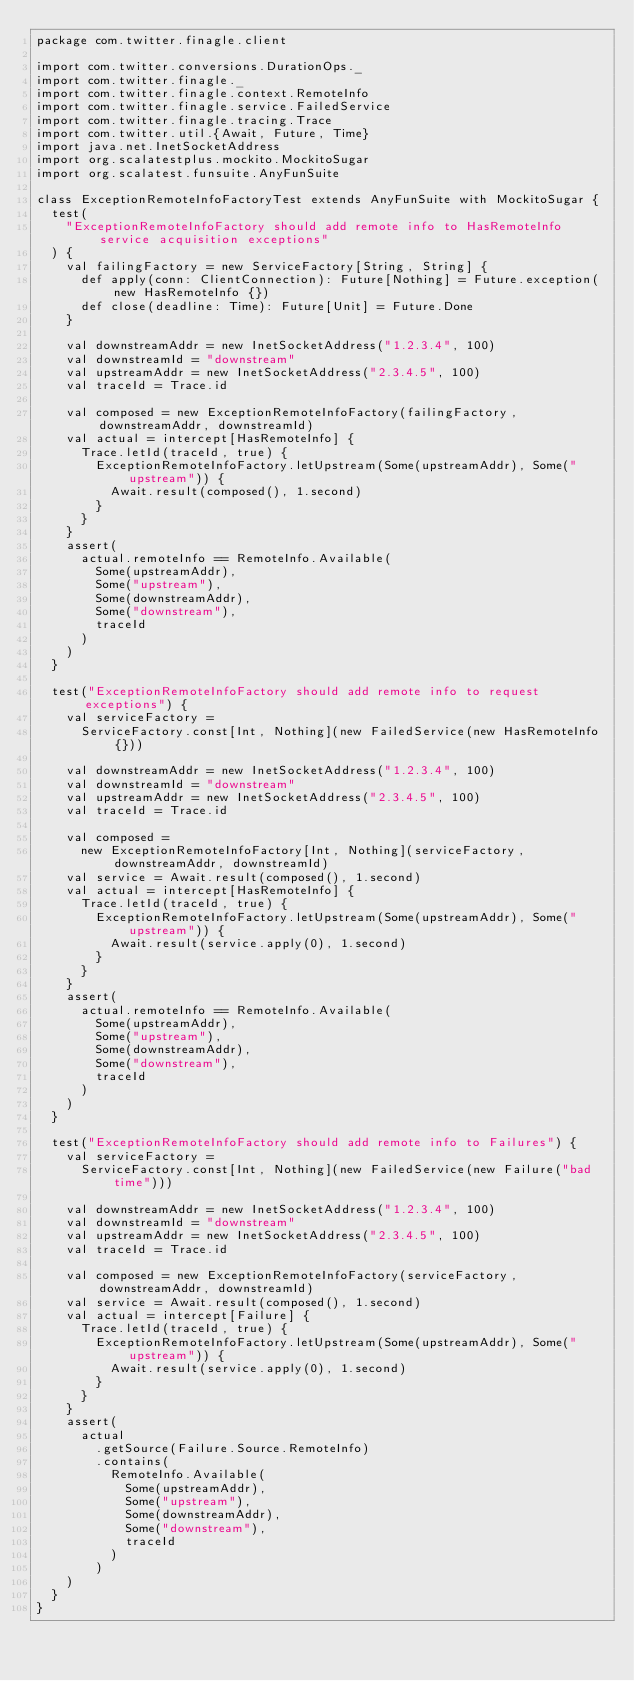Convert code to text. <code><loc_0><loc_0><loc_500><loc_500><_Scala_>package com.twitter.finagle.client

import com.twitter.conversions.DurationOps._
import com.twitter.finagle._
import com.twitter.finagle.context.RemoteInfo
import com.twitter.finagle.service.FailedService
import com.twitter.finagle.tracing.Trace
import com.twitter.util.{Await, Future, Time}
import java.net.InetSocketAddress
import org.scalatestplus.mockito.MockitoSugar
import org.scalatest.funsuite.AnyFunSuite

class ExceptionRemoteInfoFactoryTest extends AnyFunSuite with MockitoSugar {
  test(
    "ExceptionRemoteInfoFactory should add remote info to HasRemoteInfo service acquisition exceptions"
  ) {
    val failingFactory = new ServiceFactory[String, String] {
      def apply(conn: ClientConnection): Future[Nothing] = Future.exception(new HasRemoteInfo {})
      def close(deadline: Time): Future[Unit] = Future.Done
    }

    val downstreamAddr = new InetSocketAddress("1.2.3.4", 100)
    val downstreamId = "downstream"
    val upstreamAddr = new InetSocketAddress("2.3.4.5", 100)
    val traceId = Trace.id

    val composed = new ExceptionRemoteInfoFactory(failingFactory, downstreamAddr, downstreamId)
    val actual = intercept[HasRemoteInfo] {
      Trace.letId(traceId, true) {
        ExceptionRemoteInfoFactory.letUpstream(Some(upstreamAddr), Some("upstream")) {
          Await.result(composed(), 1.second)
        }
      }
    }
    assert(
      actual.remoteInfo == RemoteInfo.Available(
        Some(upstreamAddr),
        Some("upstream"),
        Some(downstreamAddr),
        Some("downstream"),
        traceId
      )
    )
  }

  test("ExceptionRemoteInfoFactory should add remote info to request exceptions") {
    val serviceFactory =
      ServiceFactory.const[Int, Nothing](new FailedService(new HasRemoteInfo {}))

    val downstreamAddr = new InetSocketAddress("1.2.3.4", 100)
    val downstreamId = "downstream"
    val upstreamAddr = new InetSocketAddress("2.3.4.5", 100)
    val traceId = Trace.id

    val composed =
      new ExceptionRemoteInfoFactory[Int, Nothing](serviceFactory, downstreamAddr, downstreamId)
    val service = Await.result(composed(), 1.second)
    val actual = intercept[HasRemoteInfo] {
      Trace.letId(traceId, true) {
        ExceptionRemoteInfoFactory.letUpstream(Some(upstreamAddr), Some("upstream")) {
          Await.result(service.apply(0), 1.second)
        }
      }
    }
    assert(
      actual.remoteInfo == RemoteInfo.Available(
        Some(upstreamAddr),
        Some("upstream"),
        Some(downstreamAddr),
        Some("downstream"),
        traceId
      )
    )
  }

  test("ExceptionRemoteInfoFactory should add remote info to Failures") {
    val serviceFactory =
      ServiceFactory.const[Int, Nothing](new FailedService(new Failure("bad time")))

    val downstreamAddr = new InetSocketAddress("1.2.3.4", 100)
    val downstreamId = "downstream"
    val upstreamAddr = new InetSocketAddress("2.3.4.5", 100)
    val traceId = Trace.id

    val composed = new ExceptionRemoteInfoFactory(serviceFactory, downstreamAddr, downstreamId)
    val service = Await.result(composed(), 1.second)
    val actual = intercept[Failure] {
      Trace.letId(traceId, true) {
        ExceptionRemoteInfoFactory.letUpstream(Some(upstreamAddr), Some("upstream")) {
          Await.result(service.apply(0), 1.second)
        }
      }
    }
    assert(
      actual
        .getSource(Failure.Source.RemoteInfo)
        .contains(
          RemoteInfo.Available(
            Some(upstreamAddr),
            Some("upstream"),
            Some(downstreamAddr),
            Some("downstream"),
            traceId
          )
        )
    )
  }
}
</code> 